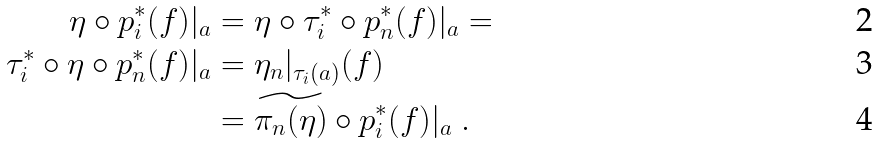Convert formula to latex. <formula><loc_0><loc_0><loc_500><loc_500>\eta \circ p _ { i } ^ { * } ( f ) | _ { a } & = \eta \circ \tau _ { i } ^ { * } \circ p _ { n } ^ { * } ( f ) | _ { a } = \\ \tau _ { i } ^ { * } \circ \eta \circ p _ { n } ^ { * } ( f ) | _ { a } & = \eta _ { n } | _ { \tau _ { i } ( a ) } ( f ) \\ & = \widetilde { \pi _ { n } ( \eta ) } \circ p _ { i } ^ { * } ( f ) | _ { a } \ .</formula> 